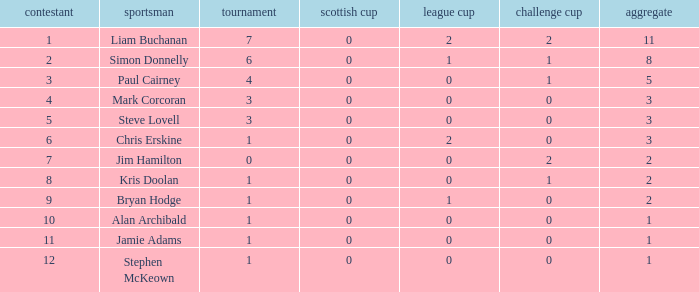What is bryan hodge's player number 1.0. Would you be able to parse every entry in this table? {'header': ['contestant', 'sportsman', 'tournament', 'scottish cup', 'league cup', 'challenge cup', 'aggregate'], 'rows': [['1', 'Liam Buchanan', '7', '0', '2', '2', '11'], ['2', 'Simon Donnelly', '6', '0', '1', '1', '8'], ['3', 'Paul Cairney', '4', '0', '0', '1', '5'], ['4', 'Mark Corcoran', '3', '0', '0', '0', '3'], ['5', 'Steve Lovell', '3', '0', '0', '0', '3'], ['6', 'Chris Erskine', '1', '0', '2', '0', '3'], ['7', 'Jim Hamilton', '0', '0', '0', '2', '2'], ['8', 'Kris Doolan', '1', '0', '0', '1', '2'], ['9', 'Bryan Hodge', '1', '0', '1', '0', '2'], ['10', 'Alan Archibald', '1', '0', '0', '0', '1'], ['11', 'Jamie Adams', '1', '0', '0', '0', '1'], ['12', 'Stephen McKeown', '1', '0', '0', '0', '1']]} 